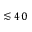Convert formula to latex. <formula><loc_0><loc_0><loc_500><loc_500>\lesssim 4 0</formula> 